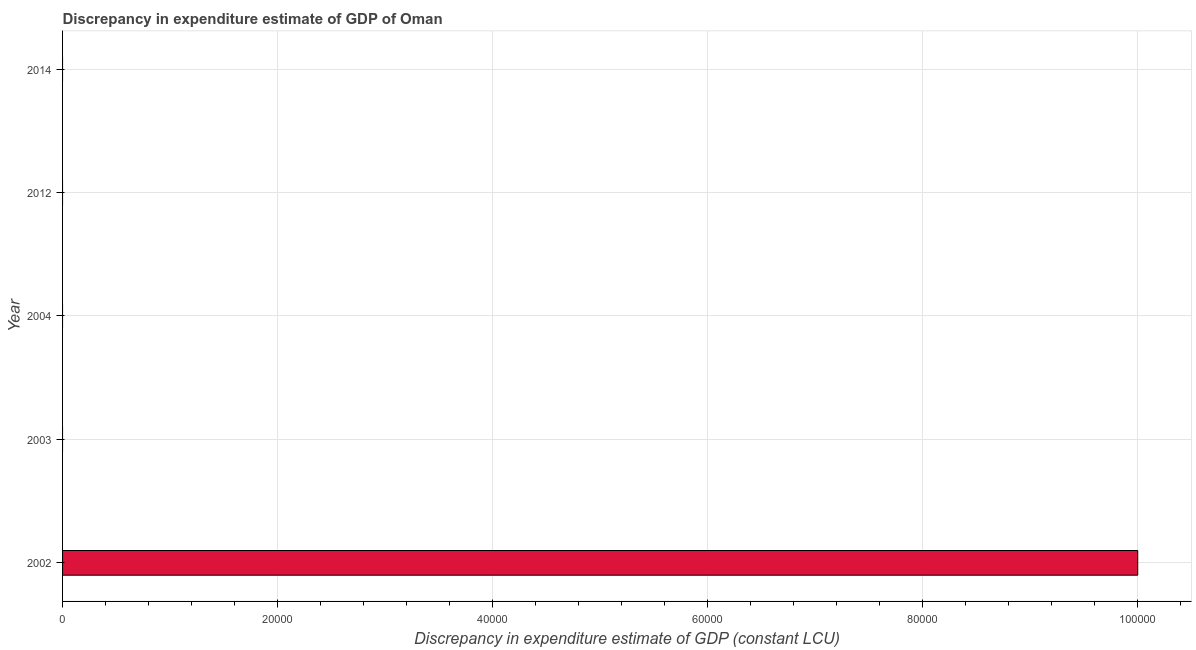What is the title of the graph?
Ensure brevity in your answer.  Discrepancy in expenditure estimate of GDP of Oman. What is the label or title of the X-axis?
Your response must be concise. Discrepancy in expenditure estimate of GDP (constant LCU). What is the label or title of the Y-axis?
Give a very brief answer. Year. Across all years, what is the maximum discrepancy in expenditure estimate of gdp?
Offer a very short reply. 1.00e+05. In which year was the discrepancy in expenditure estimate of gdp maximum?
Give a very brief answer. 2002. What is the sum of the discrepancy in expenditure estimate of gdp?
Provide a short and direct response. 1.00e+05. What is the average discrepancy in expenditure estimate of gdp per year?
Your response must be concise. 2.00e+04. What is the median discrepancy in expenditure estimate of gdp?
Your answer should be very brief. 0. Are all the bars in the graph horizontal?
Ensure brevity in your answer.  Yes. How many years are there in the graph?
Your answer should be very brief. 5. Are the values on the major ticks of X-axis written in scientific E-notation?
Give a very brief answer. No. What is the Discrepancy in expenditure estimate of GDP (constant LCU) of 2003?
Offer a terse response. 0. 